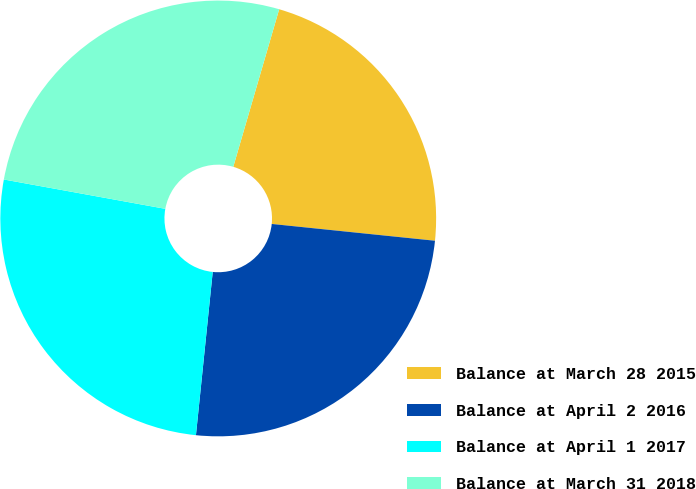Convert chart. <chart><loc_0><loc_0><loc_500><loc_500><pie_chart><fcel>Balance at March 28 2015<fcel>Balance at April 2 2016<fcel>Balance at April 1 2017<fcel>Balance at March 31 2018<nl><fcel>22.12%<fcel>25.0%<fcel>26.23%<fcel>26.65%<nl></chart> 